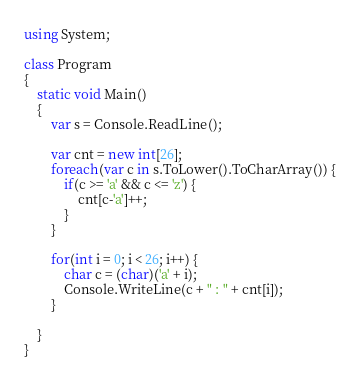Convert code to text. <code><loc_0><loc_0><loc_500><loc_500><_C#_>using System;
 
class Program
{
    static void Main()
    {
		var s = Console.ReadLine();
	
    	var cnt = new int[26];
    	foreach(var c in s.ToLower().ToCharArray()) {
    		if(c >= 'a' && c <= 'z') {
    			cnt[c-'a']++;
    		}
    	}
    	
    	for(int i = 0; i < 26; i++) {
    		char c = (char)('a' + i);
    		Console.WriteLine(c + " : " + cnt[i]);
    	}
    	
    }
}</code> 